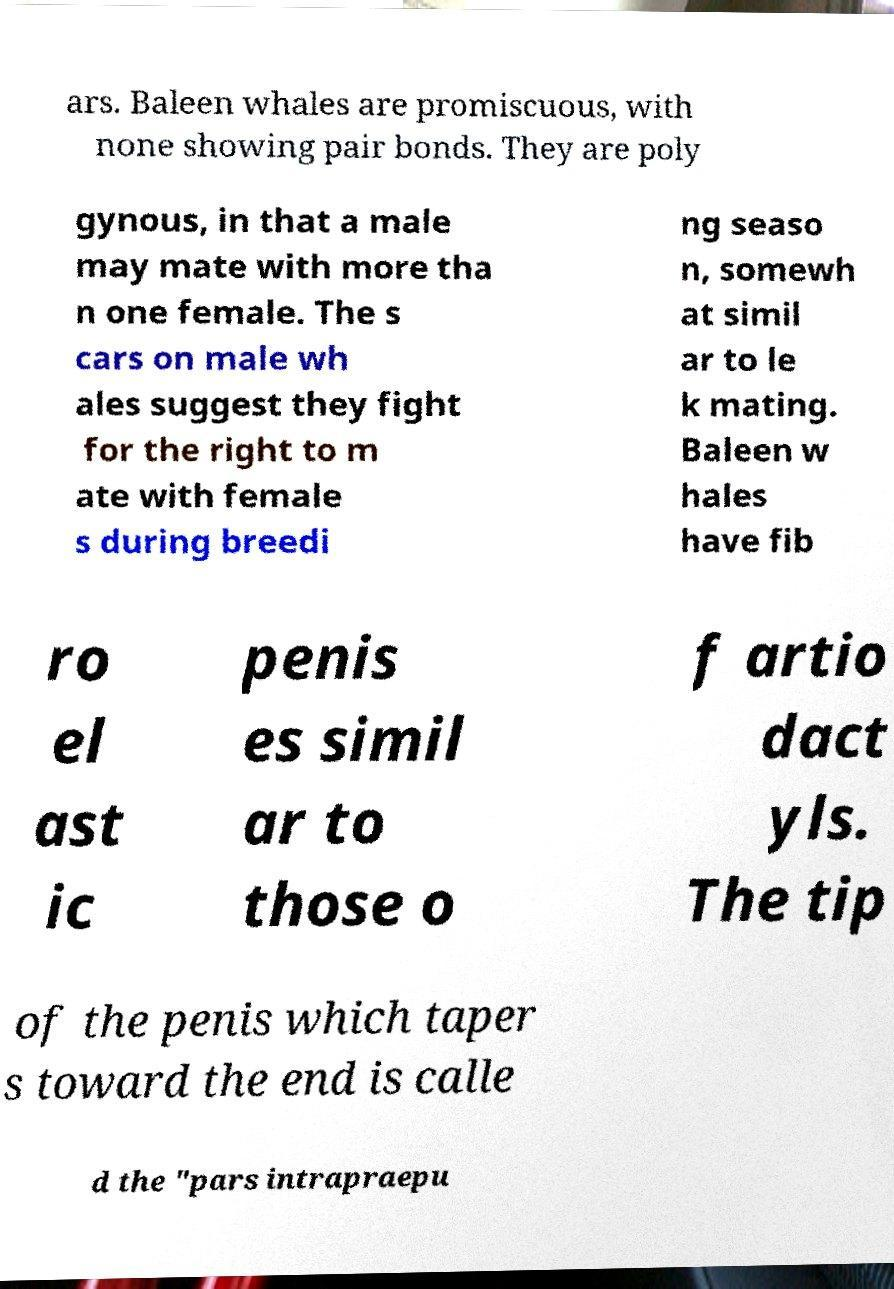I need the written content from this picture converted into text. Can you do that? ars. Baleen whales are promiscuous, with none showing pair bonds. They are poly gynous, in that a male may mate with more tha n one female. The s cars on male wh ales suggest they fight for the right to m ate with female s during breedi ng seaso n, somewh at simil ar to le k mating. Baleen w hales have fib ro el ast ic penis es simil ar to those o f artio dact yls. The tip of the penis which taper s toward the end is calle d the "pars intrapraepu 